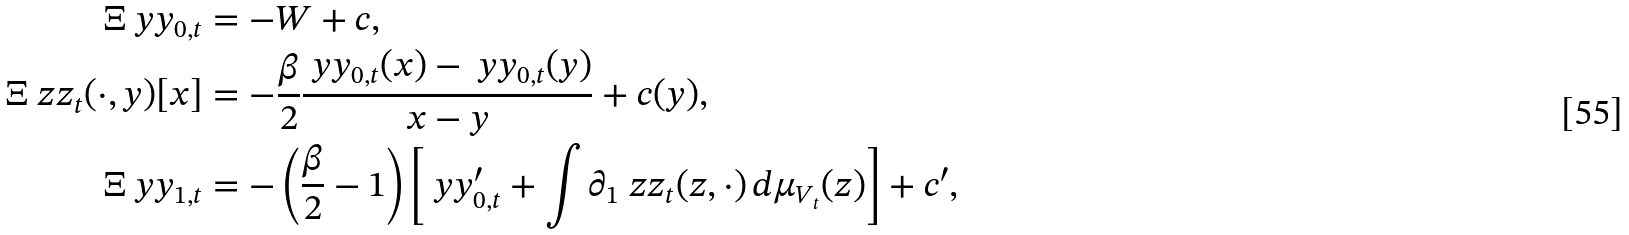<formula> <loc_0><loc_0><loc_500><loc_500>\Xi \ y y _ { 0 , t } & = - W + c , \\ \Xi \ z z _ { t } ( \cdot , y ) [ x ] & = - \frac { \beta } { 2 } \frac { \ y y _ { 0 , t } ( x ) - \ y y _ { 0 , t } ( y ) } { x - y } + c ( y ) , \\ \Xi \ y y _ { 1 , t } & = - \left ( \frac { \beta } { 2 } - 1 \right ) \left [ \ y y _ { 0 , t } ^ { \prime } + \int \partial _ { 1 } \ z z _ { t } ( z , \cdot ) \, d \mu _ { V _ { t } } ( z ) \right ] + c ^ { \prime } ,</formula> 